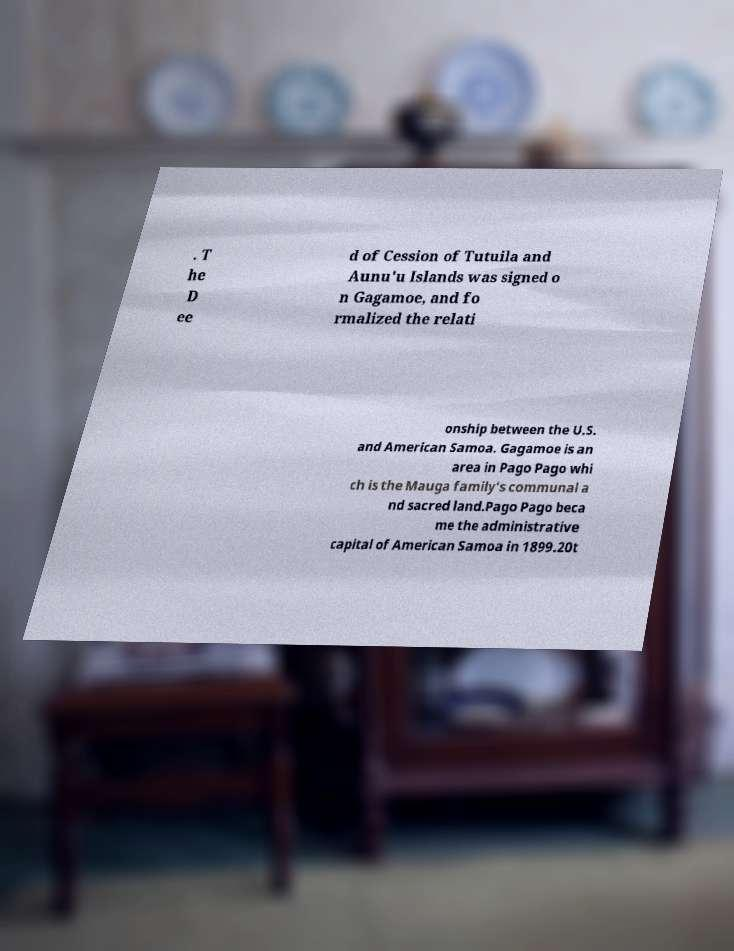I need the written content from this picture converted into text. Can you do that? . T he D ee d of Cession of Tutuila and Aunu'u Islands was signed o n Gagamoe, and fo rmalized the relati onship between the U.S. and American Samoa. Gagamoe is an area in Pago Pago whi ch is the Mauga family's communal a nd sacred land.Pago Pago beca me the administrative capital of American Samoa in 1899.20t 